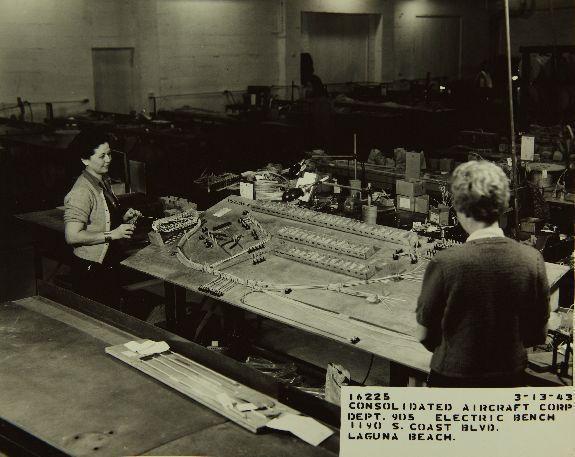How many people are there?
Give a very brief answer. 2. 